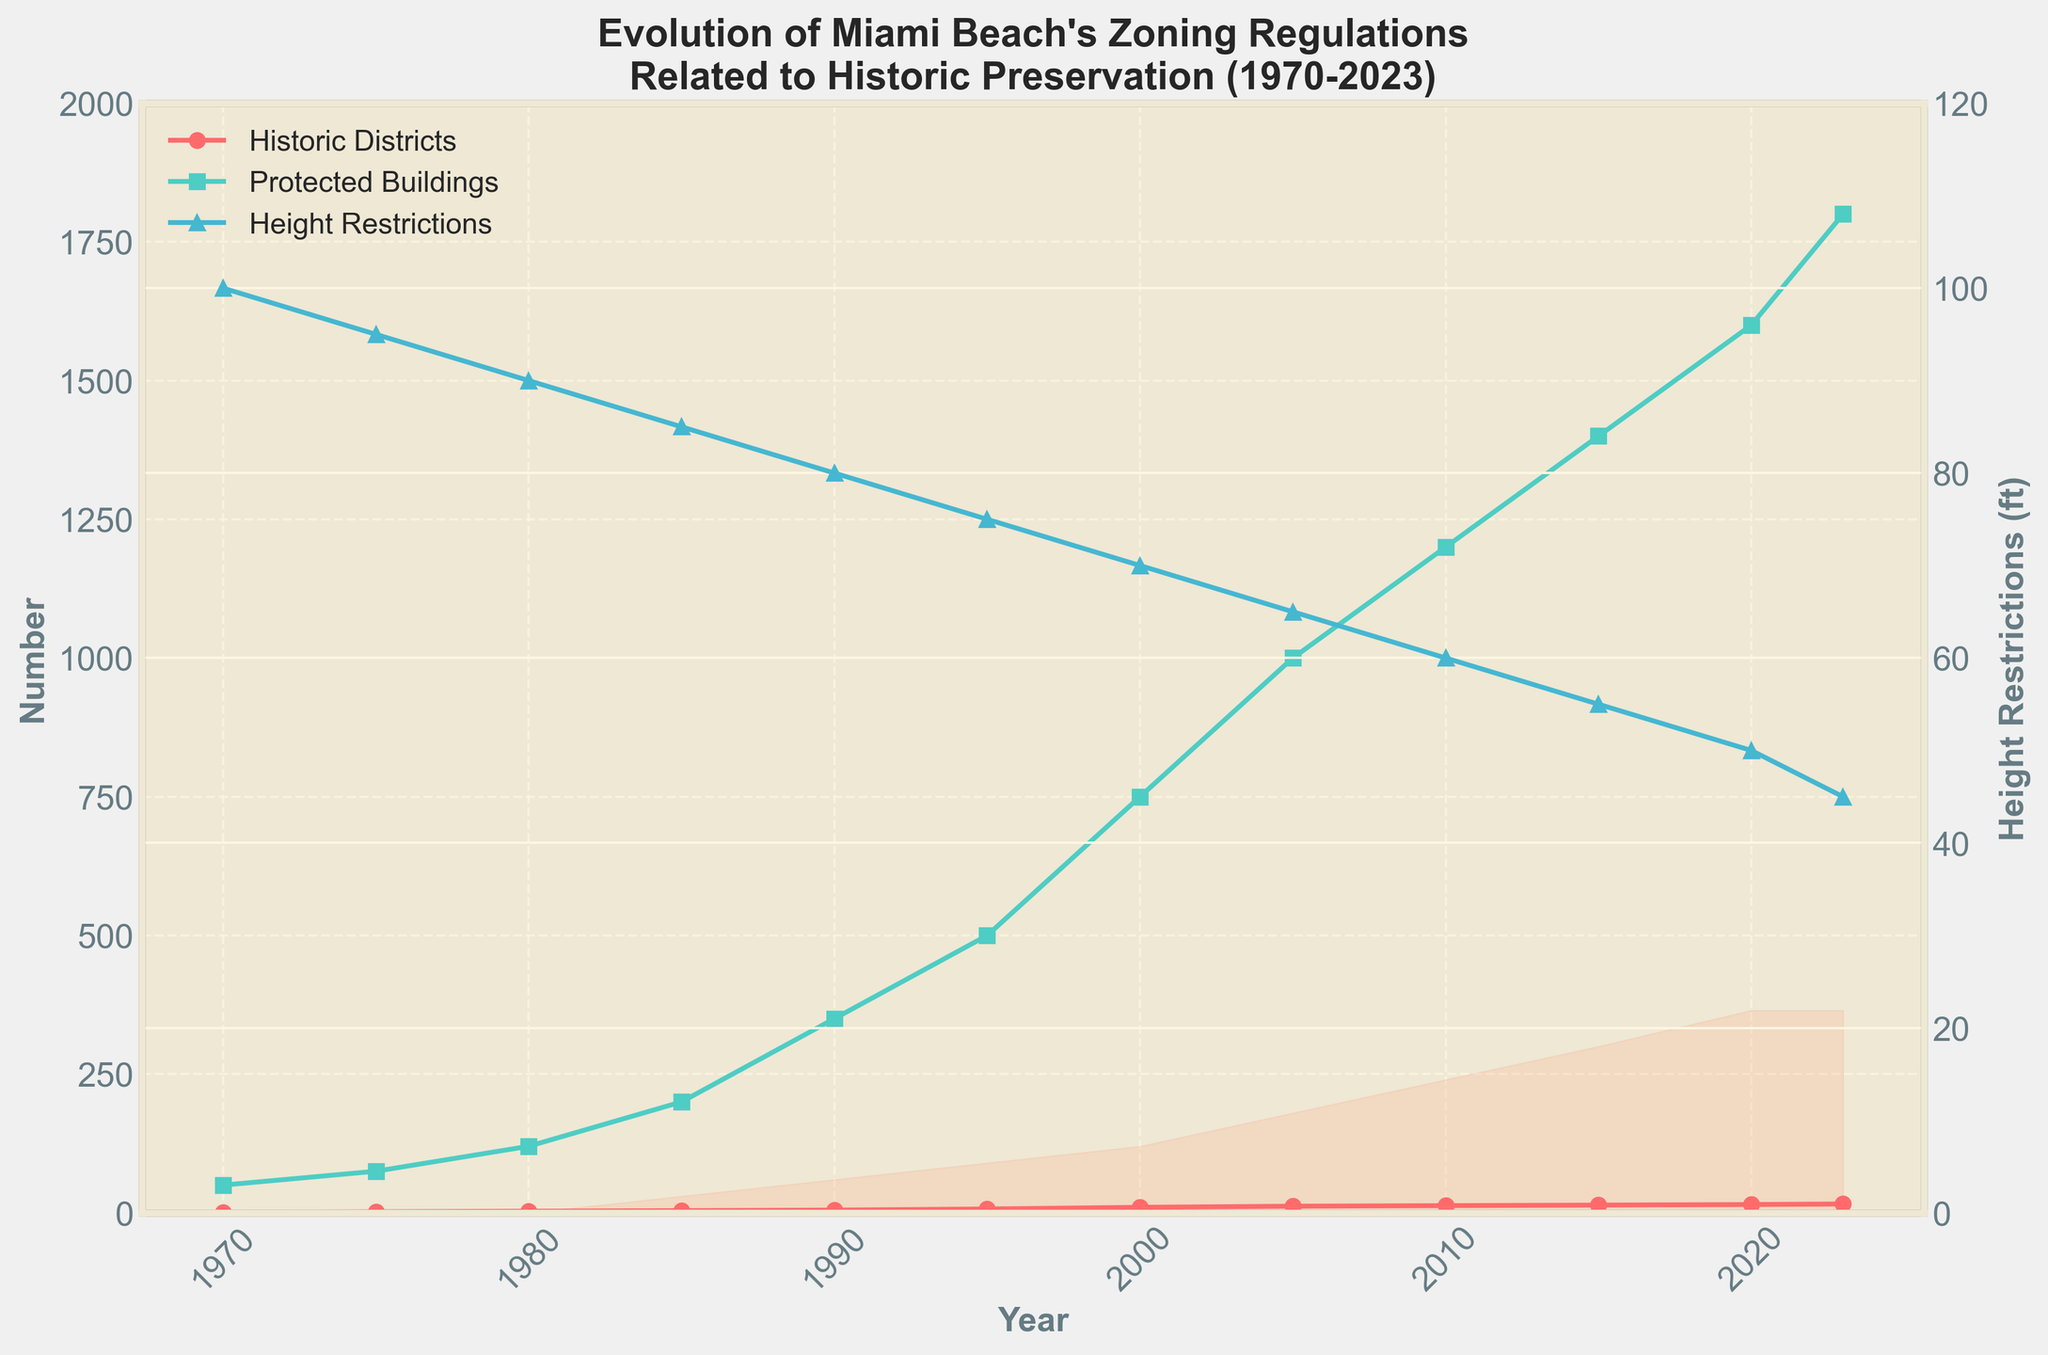What is the trend in the number of Historic Districts from 1970 to 2023? The figure shows a consistent upward trend in the number of Historic Districts over time. From 1970 to 2023, the number of Historic Districts increased steadily. This can be seen by the continuous rise of the red line with circle markers.
Answer: Consistent upward trend What year saw the highest increase in Protected Buildings compared to the previous year? By observing the green line with square markers, the steepest increase appears between 1985 and 1990, where the number of Protected Buildings jumped from 200 to 350. To find this, compare the slopes of the lines between each year.
Answer: 1985-1990 How do the Height Restrictions in feet change over the years? The blue line with triangle markers shows the Height Restrictions, which steadily decrease over time. Starting at 100 feet in 1970 and ending at 45 feet in 2023, this indicates a consistent reduction in allowable building height.
Answer: Steadily decrease Compare the Demolition Moratorium Days in 1985 and 2020. The shaded area representing Demolition Moratorium Days is at 30 days in 1985 and increases to 365 days by 2020. This shows that moratorium days have significantly increased. Compare the heights of the filled area at these two points to observe this change.
Answer: 30 days in 1985, 365 days in 2020 What is the relationship between the number of Protected Buildings and the Demolition Moratorium Days? The relationship can be inferred by comparing the green line (Protected Buildings) and the shaded area (Demolition Moratorium Days). As the number of Protected Buildings increases, the Demolition Moratorium Days also increase significantly over the same period. This can be seen from both trends rising over time.
Answer: Positive relationship What happened to the number of Historic Districts between 2000 and 2005? The red line with circle markers shows a significant increase from 10 districts in 2000 to 12 districts in 2005, indicating the establishment of 2 new Historic Districts during this period.
Answer: Increased by 2 How does the change in Height Restrictions correlate with the number of new Historic Districts from 1970 to 2023? Observing both the blue line for Height Restrictions and the red line for Historic Districts from 1970 to 2023, we see that as the number of Historic Districts increases, Height Restrictions decrease, suggesting a negative correlation.
Answer: Negative correlation What is the average number of Protected Buildings between 1980 and 2000? To find the average, add the number of Protected Buildings for the years 1980 (120), 1985 (200), 1990 (350), 1995 (500), and 2000 (750) and divide by the number of years: (120 + 200 + 350 + 500 + 750)/5 = 384
Answer: 384 In which year did the Height Restrictions first drop below 75 feet? Observing the blue line, Height Restrictions first drop below 75 feet in 1995.
Answer: 1995 Which element shows the most significant increase from 1970 to 2023? Analyzing all elements, the number of Protected Buildings (green line with square markers) shows the most significant increase, growing from 50 in 1970 to 1800 in 2023. This is a substantial upward trend.
Answer: Protected Buildings 